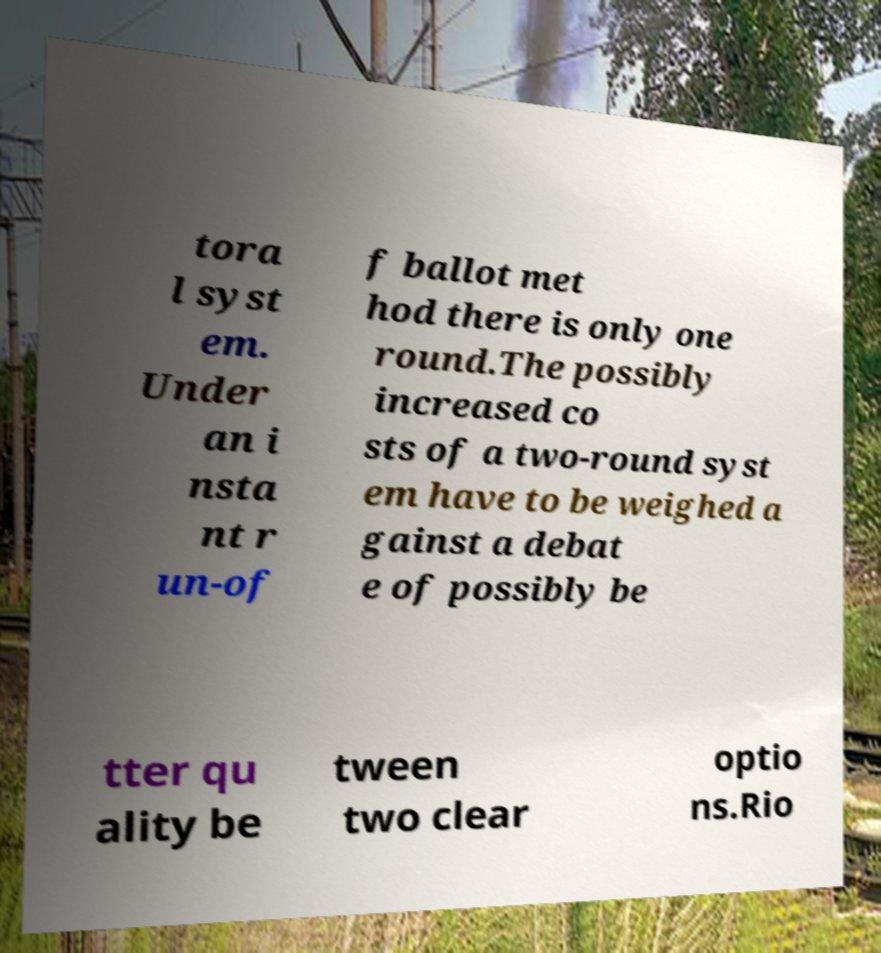Can you read and provide the text displayed in the image?This photo seems to have some interesting text. Can you extract and type it out for me? tora l syst em. Under an i nsta nt r un-of f ballot met hod there is only one round.The possibly increased co sts of a two-round syst em have to be weighed a gainst a debat e of possibly be tter qu ality be tween two clear optio ns.Rio 